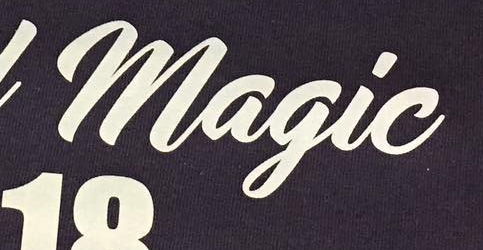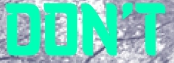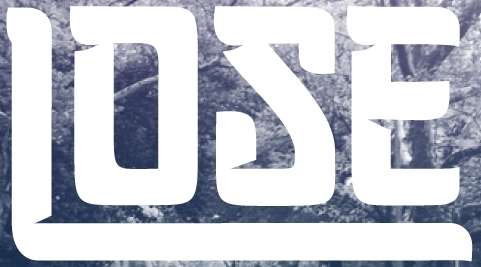What text appears in these images from left to right, separated by a semicolon? Magic; DON'T; LOSE 